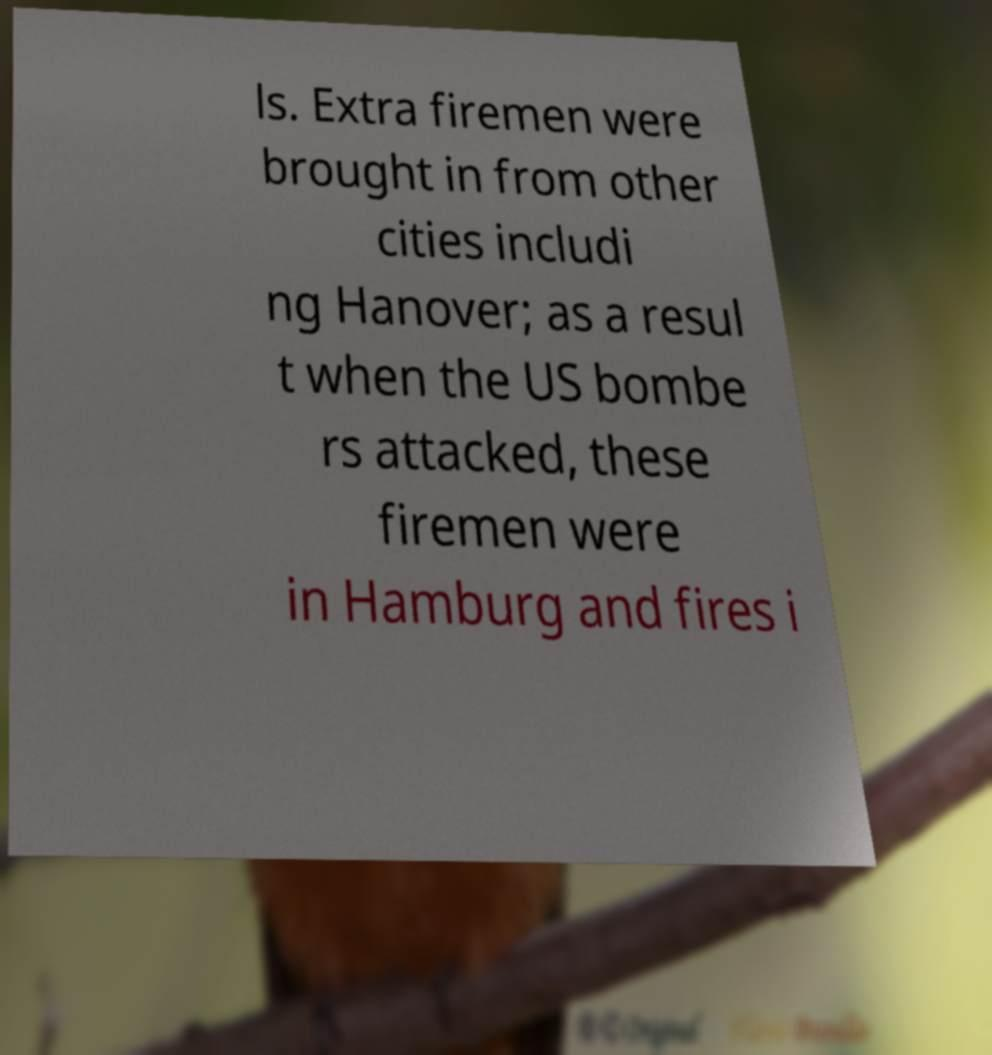Could you extract and type out the text from this image? ls. Extra firemen were brought in from other cities includi ng Hanover; as a resul t when the US bombe rs attacked, these firemen were in Hamburg and fires i 